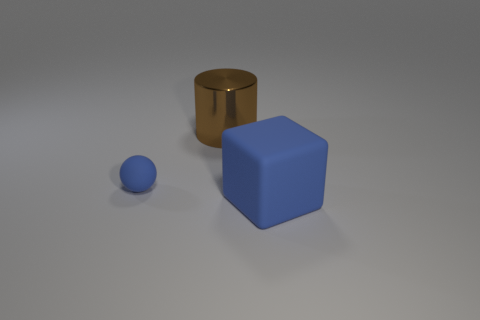Add 2 small cyan cylinders. How many objects exist? 5 Subtract all spheres. How many objects are left? 2 Add 1 cylinders. How many cylinders exist? 2 Subtract 0 green cylinders. How many objects are left? 3 Subtract all large blue matte things. Subtract all spheres. How many objects are left? 1 Add 2 metallic cylinders. How many metallic cylinders are left? 3 